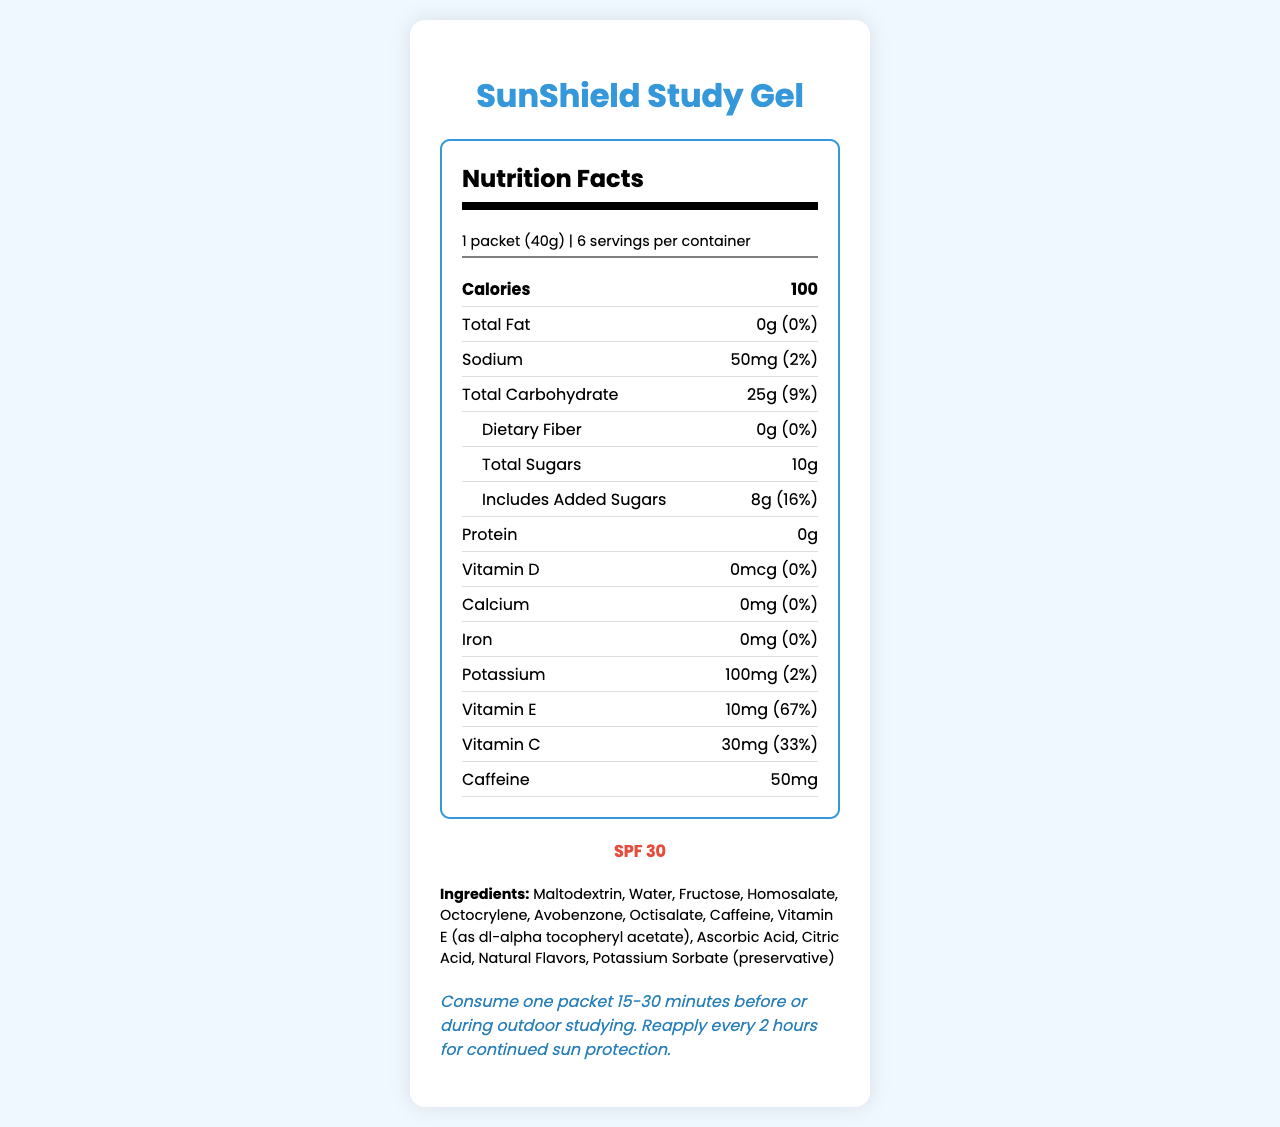what is the serving size of SunShield Study Gel? The serving size is stated at the top of the nutrition label as "1 packet (40g)".
Answer: 1 packet (40g) how many servings are there per container? The nutrition label states "6 servings per container".
Answer: 6 how many calories are in one serving? The label lists 100 calories per serving.
Answer: 100 how much total fat is in one packet? The total fat per serving is listed as 0g.
Answer: 0g how much sodium is in one serving, and what is its daily value percentage? One serving contains 50mg of sodium, which is 2% of the daily value.
Answer: 50mg and 2% how much protein is in a single packet? The label indicates that there is 0g of protein per serving.
Answer: 0g what is the SPF rating of SunShield Study Gel? The SPF rating is mentioned under "SPF 30”.
Answer: 30 how much Vitamin E is in one serving, and what is its daily value percentage? The label displays 10mg of Vitamin E, which is 67% of the daily value.
Answer: 10mg and 67% if you consume two packets, how much potassium will you ingest? Each packet contains 100mg of potassium, so two packets equal 200mg.
Answer: 200mg which ingredient is listed first? The ingredients list starts with Maltodextrin.
Answer: Maltodextrin how much added sugar does one packet contain? The label states that there are 8g of added sugars per packet.
Answer: 8g is this product suitable for people with soy allergies? The allergen information notes the product is produced in a facility that also processes soy.
Answer: No does SunShield Study Gel contain any dietary fiber? The label shows 0g of dietary fiber in each packet.
Answer: No what is the manufacturer and its address? The manufacturer's name and address are provided at the bottom of the document.
Answer: OutdoorLearn Nutrition, Inc., 123 Campus Way, College Town, ST 12345 how should SunShield Study Gel be stored? The storage instructions advise to store in a cool, dry place and avoid direct sunlight.
Answer: Store in a cool, dry place. Avoid direct sunlight. when should you consume SunShield Study Gel for optimal use? A. 15-30 minutes before outdoor studying B. During outdoor studying C. After outdoor studying D. Both A and B The usage instructions suggest consuming one packet 15-30 minutes before or during outdoor studying.
Answer: D. Both A and B what is the daily value percentage of Vitamin C in one packet? A. 33% B. 67% C. 50% D. 0% The nutrition label shows that the daily value percentage for Vitamin C is 33%.
Answer: A. 33% can the daily value percentage of caffeine be determined from this document? While the amount of caffeine is provided (50mg), there is no daily value percentage listed for caffeine.
Answer: No is the product free from all allergens? The allergen information section notes it is produced in a facility that also processes soy and tree nuts.
Answer: No summarize the main features of SunShield Study Gel based on the label The description summarizes the key nutritional information, SPF rating, usage instructions, storage guidelines, ingredients, and allergen warnings provided on the label.
Answer: SunShield Study Gel is a sunscreen-infused energy gel with 100 calories per packet. Each serving contains various nutrients, including Vitamin E and Vitamin C, and provides SPF 30 protection. The gel is free from fat, protein, and dietary fiber but contains sugars and caffeine. It must be stored in a cool, dry place and consumed before or during outdoor studying. It's produced by OutdoorLearn Nutrition, Inc., and may contain allergens like soy and tree nuts. 